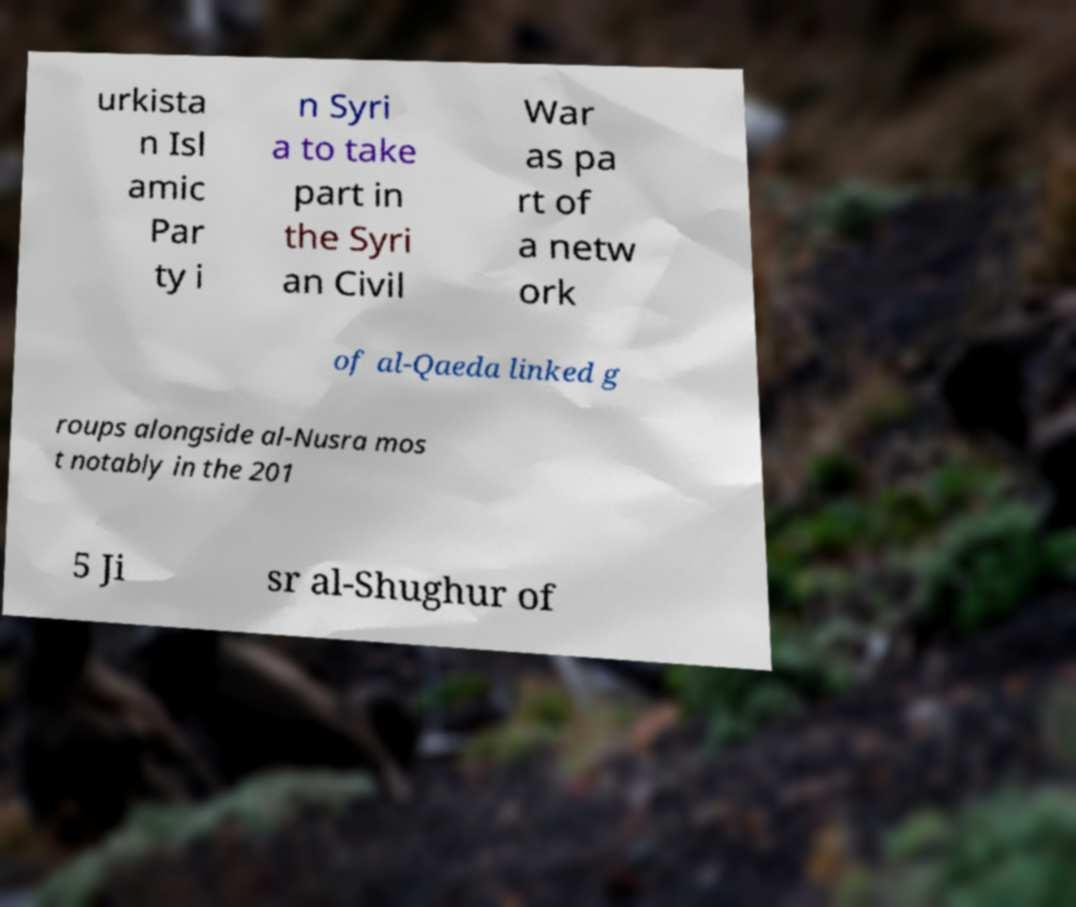Please read and relay the text visible in this image. What does it say? urkista n Isl amic Par ty i n Syri a to take part in the Syri an Civil War as pa rt of a netw ork of al-Qaeda linked g roups alongside al-Nusra mos t notably in the 201 5 Ji sr al-Shughur of 